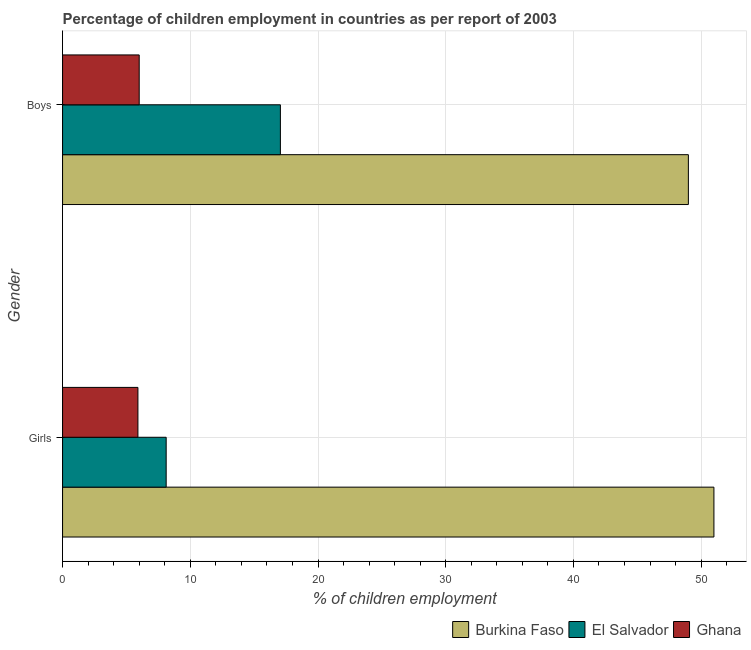Are the number of bars on each tick of the Y-axis equal?
Your response must be concise. Yes. How many bars are there on the 2nd tick from the top?
Your answer should be compact. 3. How many bars are there on the 1st tick from the bottom?
Give a very brief answer. 3. What is the label of the 1st group of bars from the top?
Provide a succinct answer. Boys. Across all countries, what is the maximum percentage of employed girls?
Ensure brevity in your answer.  51. Across all countries, what is the minimum percentage of employed boys?
Your answer should be very brief. 6. In which country was the percentage of employed girls maximum?
Ensure brevity in your answer.  Burkina Faso. What is the total percentage of employed girls in the graph?
Give a very brief answer. 65.01. What is the difference between the percentage of employed boys in El Salvador and that in Ghana?
Ensure brevity in your answer.  11.06. What is the difference between the percentage of employed boys in Ghana and the percentage of employed girls in El Salvador?
Provide a succinct answer. -2.11. What is the average percentage of employed boys per country?
Offer a terse response. 24.02. What is the difference between the percentage of employed boys and percentage of employed girls in Ghana?
Ensure brevity in your answer.  0.1. What is the ratio of the percentage of employed girls in El Salvador to that in Ghana?
Make the answer very short. 1.38. What does the 3rd bar from the top in Boys represents?
Offer a very short reply. Burkina Faso. What does the 1st bar from the bottom in Boys represents?
Your response must be concise. Burkina Faso. How many bars are there?
Offer a terse response. 6. What is the difference between two consecutive major ticks on the X-axis?
Give a very brief answer. 10. Are the values on the major ticks of X-axis written in scientific E-notation?
Your answer should be very brief. No. Does the graph contain any zero values?
Give a very brief answer. No. How many legend labels are there?
Offer a very short reply. 3. How are the legend labels stacked?
Make the answer very short. Horizontal. What is the title of the graph?
Your response must be concise. Percentage of children employment in countries as per report of 2003. What is the label or title of the X-axis?
Make the answer very short. % of children employment. What is the label or title of the Y-axis?
Provide a short and direct response. Gender. What is the % of children employment in El Salvador in Girls?
Ensure brevity in your answer.  8.11. What is the % of children employment in Ghana in Girls?
Your answer should be very brief. 5.9. What is the % of children employment of Burkina Faso in Boys?
Ensure brevity in your answer.  49. What is the % of children employment in El Salvador in Boys?
Your response must be concise. 17.06. What is the % of children employment in Ghana in Boys?
Give a very brief answer. 6. Across all Gender, what is the maximum % of children employment of Burkina Faso?
Offer a terse response. 51. Across all Gender, what is the maximum % of children employment in El Salvador?
Your response must be concise. 17.06. Across all Gender, what is the minimum % of children employment in Burkina Faso?
Your answer should be compact. 49. Across all Gender, what is the minimum % of children employment of El Salvador?
Make the answer very short. 8.11. What is the total % of children employment of Burkina Faso in the graph?
Provide a succinct answer. 100. What is the total % of children employment of El Salvador in the graph?
Ensure brevity in your answer.  25.17. What is the difference between the % of children employment in Burkina Faso in Girls and that in Boys?
Provide a succinct answer. 2. What is the difference between the % of children employment in El Salvador in Girls and that in Boys?
Provide a succinct answer. -8.94. What is the difference between the % of children employment of Ghana in Girls and that in Boys?
Make the answer very short. -0.1. What is the difference between the % of children employment of Burkina Faso in Girls and the % of children employment of El Salvador in Boys?
Your answer should be compact. 33.94. What is the difference between the % of children employment of El Salvador in Girls and the % of children employment of Ghana in Boys?
Keep it short and to the point. 2.11. What is the average % of children employment in El Salvador per Gender?
Provide a short and direct response. 12.58. What is the average % of children employment in Ghana per Gender?
Provide a succinct answer. 5.95. What is the difference between the % of children employment in Burkina Faso and % of children employment in El Salvador in Girls?
Offer a very short reply. 42.89. What is the difference between the % of children employment of Burkina Faso and % of children employment of Ghana in Girls?
Make the answer very short. 45.1. What is the difference between the % of children employment of El Salvador and % of children employment of Ghana in Girls?
Provide a succinct answer. 2.21. What is the difference between the % of children employment in Burkina Faso and % of children employment in El Salvador in Boys?
Give a very brief answer. 31.94. What is the difference between the % of children employment in El Salvador and % of children employment in Ghana in Boys?
Provide a succinct answer. 11.06. What is the ratio of the % of children employment in Burkina Faso in Girls to that in Boys?
Ensure brevity in your answer.  1.04. What is the ratio of the % of children employment of El Salvador in Girls to that in Boys?
Make the answer very short. 0.48. What is the ratio of the % of children employment in Ghana in Girls to that in Boys?
Offer a very short reply. 0.98. What is the difference between the highest and the second highest % of children employment in Burkina Faso?
Ensure brevity in your answer.  2. What is the difference between the highest and the second highest % of children employment in El Salvador?
Your answer should be very brief. 8.94. What is the difference between the highest and the lowest % of children employment in El Salvador?
Provide a short and direct response. 8.94. What is the difference between the highest and the lowest % of children employment of Ghana?
Your answer should be compact. 0.1. 